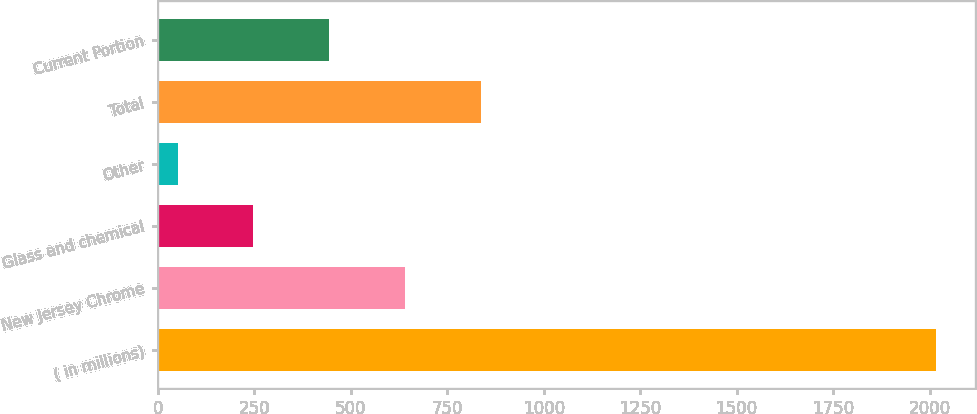Convert chart. <chart><loc_0><loc_0><loc_500><loc_500><bar_chart><fcel>( in millions)<fcel>New Jersey Chrome<fcel>Glass and chemical<fcel>Other<fcel>Total<fcel>Current Portion<nl><fcel>2017<fcel>640.8<fcel>247.6<fcel>51<fcel>837.4<fcel>444.2<nl></chart> 